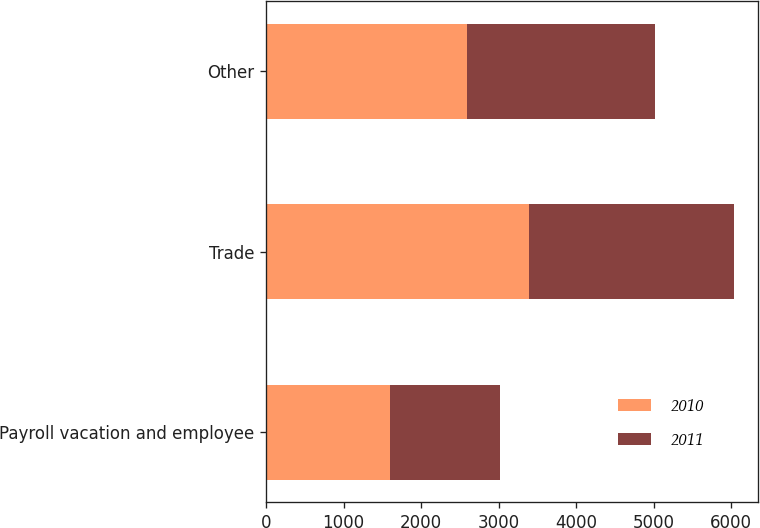Convert chart to OTSL. <chart><loc_0><loc_0><loc_500><loc_500><stacked_bar_chart><ecel><fcel>Payroll vacation and employee<fcel>Trade<fcel>Other<nl><fcel>2010<fcel>1597<fcel>3389<fcel>2593<nl><fcel>2011<fcel>1414<fcel>2649<fcel>2425<nl></chart> 